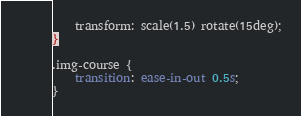Convert code to text. <code><loc_0><loc_0><loc_500><loc_500><_CSS_>    transform: scale(1.5) rotate(15deg);
}

.img-course {
    transition: ease-in-out 0.5s;
}
</code> 